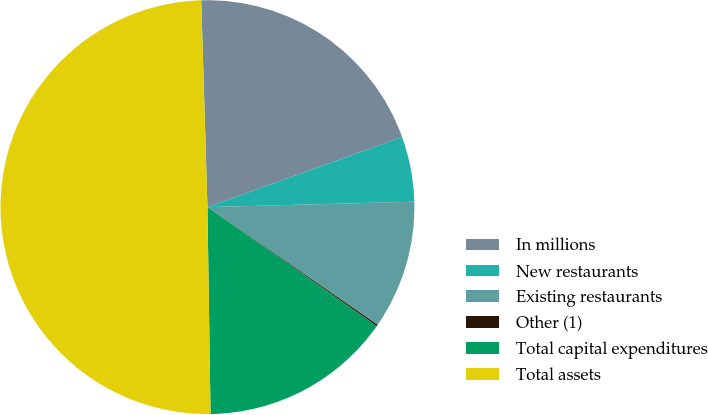<chart> <loc_0><loc_0><loc_500><loc_500><pie_chart><fcel>In millions<fcel>New restaurants<fcel>Existing restaurants<fcel>Other (1)<fcel>Total capital expenditures<fcel>Total assets<nl><fcel>19.98%<fcel>5.08%<fcel>10.05%<fcel>0.12%<fcel>15.01%<fcel>49.76%<nl></chart> 